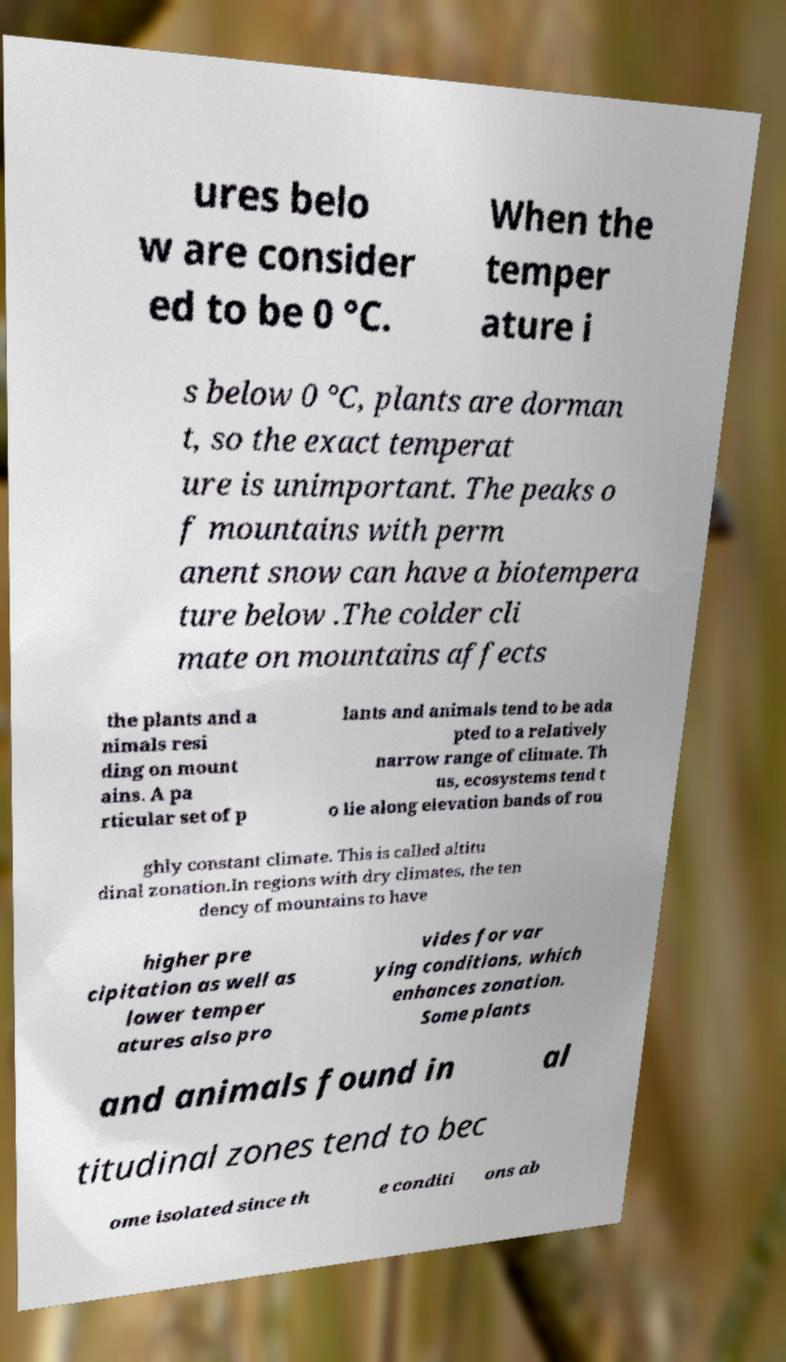What messages or text are displayed in this image? I need them in a readable, typed format. ures belo w are consider ed to be 0 °C. When the temper ature i s below 0 °C, plants are dorman t, so the exact temperat ure is unimportant. The peaks o f mountains with perm anent snow can have a biotempera ture below .The colder cli mate on mountains affects the plants and a nimals resi ding on mount ains. A pa rticular set of p lants and animals tend to be ada pted to a relatively narrow range of climate. Th us, ecosystems tend t o lie along elevation bands of rou ghly constant climate. This is called altitu dinal zonation.In regions with dry climates, the ten dency of mountains to have higher pre cipitation as well as lower temper atures also pro vides for var ying conditions, which enhances zonation. Some plants and animals found in al titudinal zones tend to bec ome isolated since th e conditi ons ab 